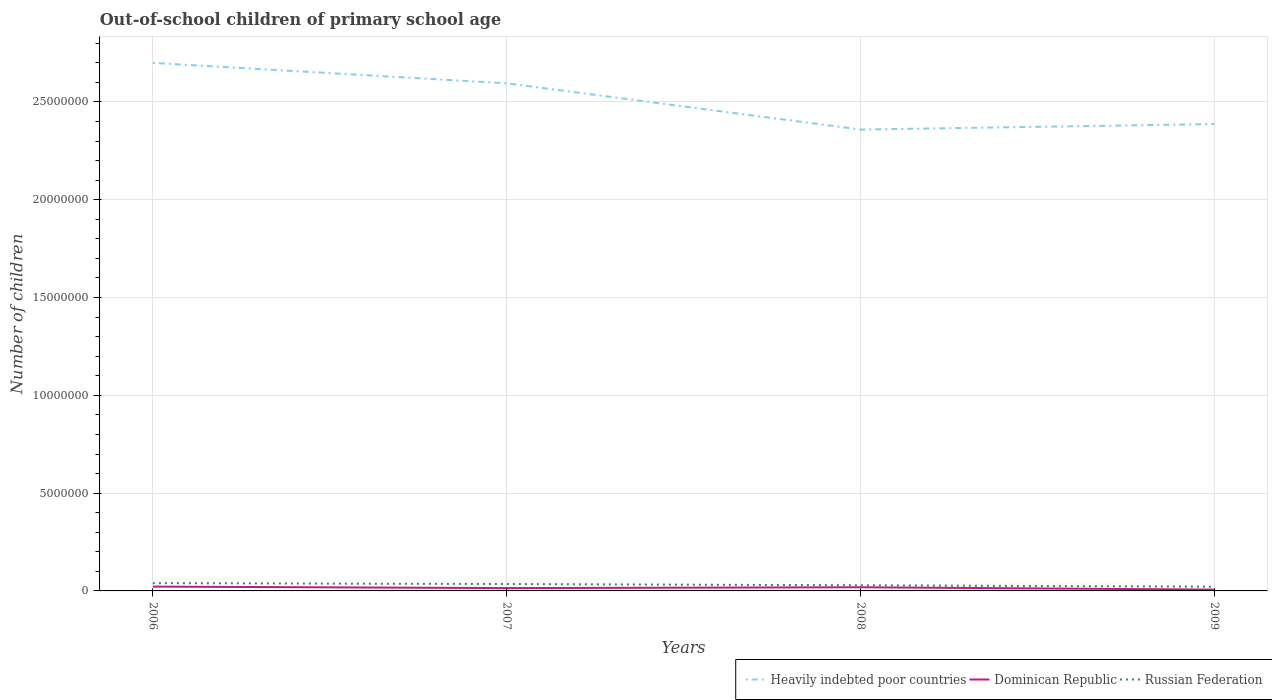How many different coloured lines are there?
Offer a very short reply. 3. Does the line corresponding to Dominican Republic intersect with the line corresponding to Russian Federation?
Offer a terse response. No. Is the number of lines equal to the number of legend labels?
Make the answer very short. Yes. Across all years, what is the maximum number of out-of-school children in Heavily indebted poor countries?
Offer a terse response. 2.36e+07. In which year was the number of out-of-school children in Russian Federation maximum?
Offer a terse response. 2009. What is the total number of out-of-school children in Heavily indebted poor countries in the graph?
Your answer should be very brief. 3.41e+06. What is the difference between the highest and the second highest number of out-of-school children in Dominican Republic?
Provide a short and direct response. 1.54e+05. Is the number of out-of-school children in Heavily indebted poor countries strictly greater than the number of out-of-school children in Dominican Republic over the years?
Offer a terse response. No. How many lines are there?
Offer a very short reply. 3. How many years are there in the graph?
Keep it short and to the point. 4. Does the graph contain any zero values?
Give a very brief answer. No. How are the legend labels stacked?
Offer a very short reply. Horizontal. What is the title of the graph?
Offer a terse response. Out-of-school children of primary school age. Does "Uruguay" appear as one of the legend labels in the graph?
Make the answer very short. No. What is the label or title of the Y-axis?
Give a very brief answer. Number of children. What is the Number of children of Heavily indebted poor countries in 2006?
Ensure brevity in your answer.  2.70e+07. What is the Number of children in Dominican Republic in 2006?
Make the answer very short. 2.21e+05. What is the Number of children of Russian Federation in 2006?
Provide a succinct answer. 3.97e+05. What is the Number of children of Heavily indebted poor countries in 2007?
Make the answer very short. 2.60e+07. What is the Number of children of Dominican Republic in 2007?
Your answer should be compact. 1.45e+05. What is the Number of children of Russian Federation in 2007?
Keep it short and to the point. 3.53e+05. What is the Number of children in Heavily indebted poor countries in 2008?
Make the answer very short. 2.36e+07. What is the Number of children of Dominican Republic in 2008?
Give a very brief answer. 1.87e+05. What is the Number of children of Russian Federation in 2008?
Your answer should be very brief. 2.88e+05. What is the Number of children in Heavily indebted poor countries in 2009?
Ensure brevity in your answer.  2.39e+07. What is the Number of children in Dominican Republic in 2009?
Your answer should be very brief. 6.76e+04. What is the Number of children of Russian Federation in 2009?
Your answer should be very brief. 2.18e+05. Across all years, what is the maximum Number of children of Heavily indebted poor countries?
Your answer should be compact. 2.70e+07. Across all years, what is the maximum Number of children in Dominican Republic?
Your answer should be very brief. 2.21e+05. Across all years, what is the maximum Number of children in Russian Federation?
Your answer should be very brief. 3.97e+05. Across all years, what is the minimum Number of children in Heavily indebted poor countries?
Your answer should be compact. 2.36e+07. Across all years, what is the minimum Number of children in Dominican Republic?
Make the answer very short. 6.76e+04. Across all years, what is the minimum Number of children of Russian Federation?
Ensure brevity in your answer.  2.18e+05. What is the total Number of children in Heavily indebted poor countries in the graph?
Make the answer very short. 1.00e+08. What is the total Number of children in Dominican Republic in the graph?
Provide a short and direct response. 6.20e+05. What is the total Number of children in Russian Federation in the graph?
Ensure brevity in your answer.  1.26e+06. What is the difference between the Number of children in Heavily indebted poor countries in 2006 and that in 2007?
Offer a terse response. 1.04e+06. What is the difference between the Number of children in Dominican Republic in 2006 and that in 2007?
Ensure brevity in your answer.  7.65e+04. What is the difference between the Number of children in Russian Federation in 2006 and that in 2007?
Provide a short and direct response. 4.47e+04. What is the difference between the Number of children in Heavily indebted poor countries in 2006 and that in 2008?
Your answer should be compact. 3.41e+06. What is the difference between the Number of children of Dominican Republic in 2006 and that in 2008?
Ensure brevity in your answer.  3.45e+04. What is the difference between the Number of children of Russian Federation in 2006 and that in 2008?
Provide a short and direct response. 1.10e+05. What is the difference between the Number of children in Heavily indebted poor countries in 2006 and that in 2009?
Give a very brief answer. 3.13e+06. What is the difference between the Number of children in Dominican Republic in 2006 and that in 2009?
Your answer should be compact. 1.54e+05. What is the difference between the Number of children of Russian Federation in 2006 and that in 2009?
Offer a terse response. 1.80e+05. What is the difference between the Number of children in Heavily indebted poor countries in 2007 and that in 2008?
Give a very brief answer. 2.36e+06. What is the difference between the Number of children in Dominican Republic in 2007 and that in 2008?
Your answer should be very brief. -4.20e+04. What is the difference between the Number of children of Russian Federation in 2007 and that in 2008?
Provide a succinct answer. 6.51e+04. What is the difference between the Number of children in Heavily indebted poor countries in 2007 and that in 2009?
Provide a succinct answer. 2.08e+06. What is the difference between the Number of children in Dominican Republic in 2007 and that in 2009?
Your answer should be compact. 7.72e+04. What is the difference between the Number of children in Russian Federation in 2007 and that in 2009?
Provide a short and direct response. 1.35e+05. What is the difference between the Number of children of Heavily indebted poor countries in 2008 and that in 2009?
Make the answer very short. -2.81e+05. What is the difference between the Number of children of Dominican Republic in 2008 and that in 2009?
Offer a very short reply. 1.19e+05. What is the difference between the Number of children in Russian Federation in 2008 and that in 2009?
Your response must be concise. 7.01e+04. What is the difference between the Number of children in Heavily indebted poor countries in 2006 and the Number of children in Dominican Republic in 2007?
Give a very brief answer. 2.69e+07. What is the difference between the Number of children in Heavily indebted poor countries in 2006 and the Number of children in Russian Federation in 2007?
Give a very brief answer. 2.66e+07. What is the difference between the Number of children of Dominican Republic in 2006 and the Number of children of Russian Federation in 2007?
Your answer should be compact. -1.31e+05. What is the difference between the Number of children of Heavily indebted poor countries in 2006 and the Number of children of Dominican Republic in 2008?
Ensure brevity in your answer.  2.68e+07. What is the difference between the Number of children of Heavily indebted poor countries in 2006 and the Number of children of Russian Federation in 2008?
Provide a short and direct response. 2.67e+07. What is the difference between the Number of children of Dominican Republic in 2006 and the Number of children of Russian Federation in 2008?
Your answer should be compact. -6.64e+04. What is the difference between the Number of children of Heavily indebted poor countries in 2006 and the Number of children of Dominican Republic in 2009?
Offer a very short reply. 2.69e+07. What is the difference between the Number of children of Heavily indebted poor countries in 2006 and the Number of children of Russian Federation in 2009?
Your answer should be compact. 2.68e+07. What is the difference between the Number of children of Dominican Republic in 2006 and the Number of children of Russian Federation in 2009?
Offer a terse response. 3704. What is the difference between the Number of children in Heavily indebted poor countries in 2007 and the Number of children in Dominican Republic in 2008?
Keep it short and to the point. 2.58e+07. What is the difference between the Number of children in Heavily indebted poor countries in 2007 and the Number of children in Russian Federation in 2008?
Make the answer very short. 2.57e+07. What is the difference between the Number of children of Dominican Republic in 2007 and the Number of children of Russian Federation in 2008?
Make the answer very short. -1.43e+05. What is the difference between the Number of children of Heavily indebted poor countries in 2007 and the Number of children of Dominican Republic in 2009?
Ensure brevity in your answer.  2.59e+07. What is the difference between the Number of children in Heavily indebted poor countries in 2007 and the Number of children in Russian Federation in 2009?
Offer a very short reply. 2.57e+07. What is the difference between the Number of children of Dominican Republic in 2007 and the Number of children of Russian Federation in 2009?
Ensure brevity in your answer.  -7.28e+04. What is the difference between the Number of children of Heavily indebted poor countries in 2008 and the Number of children of Dominican Republic in 2009?
Provide a succinct answer. 2.35e+07. What is the difference between the Number of children in Heavily indebted poor countries in 2008 and the Number of children in Russian Federation in 2009?
Your answer should be very brief. 2.34e+07. What is the difference between the Number of children in Dominican Republic in 2008 and the Number of children in Russian Federation in 2009?
Provide a succinct answer. -3.08e+04. What is the average Number of children of Heavily indebted poor countries per year?
Keep it short and to the point. 2.51e+07. What is the average Number of children of Dominican Republic per year?
Your answer should be compact. 1.55e+05. What is the average Number of children of Russian Federation per year?
Offer a terse response. 3.14e+05. In the year 2006, what is the difference between the Number of children of Heavily indebted poor countries and Number of children of Dominican Republic?
Make the answer very short. 2.68e+07. In the year 2006, what is the difference between the Number of children of Heavily indebted poor countries and Number of children of Russian Federation?
Your response must be concise. 2.66e+07. In the year 2006, what is the difference between the Number of children in Dominican Republic and Number of children in Russian Federation?
Offer a very short reply. -1.76e+05. In the year 2007, what is the difference between the Number of children in Heavily indebted poor countries and Number of children in Dominican Republic?
Ensure brevity in your answer.  2.58e+07. In the year 2007, what is the difference between the Number of children of Heavily indebted poor countries and Number of children of Russian Federation?
Provide a succinct answer. 2.56e+07. In the year 2007, what is the difference between the Number of children of Dominican Republic and Number of children of Russian Federation?
Provide a succinct answer. -2.08e+05. In the year 2008, what is the difference between the Number of children of Heavily indebted poor countries and Number of children of Dominican Republic?
Provide a short and direct response. 2.34e+07. In the year 2008, what is the difference between the Number of children in Heavily indebted poor countries and Number of children in Russian Federation?
Provide a succinct answer. 2.33e+07. In the year 2008, what is the difference between the Number of children of Dominican Republic and Number of children of Russian Federation?
Offer a very short reply. -1.01e+05. In the year 2009, what is the difference between the Number of children of Heavily indebted poor countries and Number of children of Dominican Republic?
Your answer should be very brief. 2.38e+07. In the year 2009, what is the difference between the Number of children of Heavily indebted poor countries and Number of children of Russian Federation?
Your answer should be very brief. 2.37e+07. In the year 2009, what is the difference between the Number of children in Dominican Republic and Number of children in Russian Federation?
Provide a succinct answer. -1.50e+05. What is the ratio of the Number of children of Heavily indebted poor countries in 2006 to that in 2007?
Make the answer very short. 1.04. What is the ratio of the Number of children of Dominican Republic in 2006 to that in 2007?
Offer a terse response. 1.53. What is the ratio of the Number of children of Russian Federation in 2006 to that in 2007?
Offer a terse response. 1.13. What is the ratio of the Number of children in Heavily indebted poor countries in 2006 to that in 2008?
Your answer should be very brief. 1.14. What is the ratio of the Number of children of Dominican Republic in 2006 to that in 2008?
Your response must be concise. 1.18. What is the ratio of the Number of children in Russian Federation in 2006 to that in 2008?
Keep it short and to the point. 1.38. What is the ratio of the Number of children in Heavily indebted poor countries in 2006 to that in 2009?
Keep it short and to the point. 1.13. What is the ratio of the Number of children in Dominican Republic in 2006 to that in 2009?
Your answer should be compact. 3.27. What is the ratio of the Number of children of Russian Federation in 2006 to that in 2009?
Provide a succinct answer. 1.83. What is the ratio of the Number of children of Heavily indebted poor countries in 2007 to that in 2008?
Make the answer very short. 1.1. What is the ratio of the Number of children in Dominican Republic in 2007 to that in 2008?
Provide a short and direct response. 0.78. What is the ratio of the Number of children in Russian Federation in 2007 to that in 2008?
Your answer should be compact. 1.23. What is the ratio of the Number of children in Heavily indebted poor countries in 2007 to that in 2009?
Keep it short and to the point. 1.09. What is the ratio of the Number of children in Dominican Republic in 2007 to that in 2009?
Provide a succinct answer. 2.14. What is the ratio of the Number of children of Russian Federation in 2007 to that in 2009?
Provide a succinct answer. 1.62. What is the ratio of the Number of children in Heavily indebted poor countries in 2008 to that in 2009?
Your answer should be compact. 0.99. What is the ratio of the Number of children of Dominican Republic in 2008 to that in 2009?
Ensure brevity in your answer.  2.76. What is the ratio of the Number of children in Russian Federation in 2008 to that in 2009?
Offer a very short reply. 1.32. What is the difference between the highest and the second highest Number of children of Heavily indebted poor countries?
Make the answer very short. 1.04e+06. What is the difference between the highest and the second highest Number of children in Dominican Republic?
Provide a short and direct response. 3.45e+04. What is the difference between the highest and the second highest Number of children of Russian Federation?
Your response must be concise. 4.47e+04. What is the difference between the highest and the lowest Number of children in Heavily indebted poor countries?
Ensure brevity in your answer.  3.41e+06. What is the difference between the highest and the lowest Number of children of Dominican Republic?
Provide a succinct answer. 1.54e+05. What is the difference between the highest and the lowest Number of children in Russian Federation?
Give a very brief answer. 1.80e+05. 